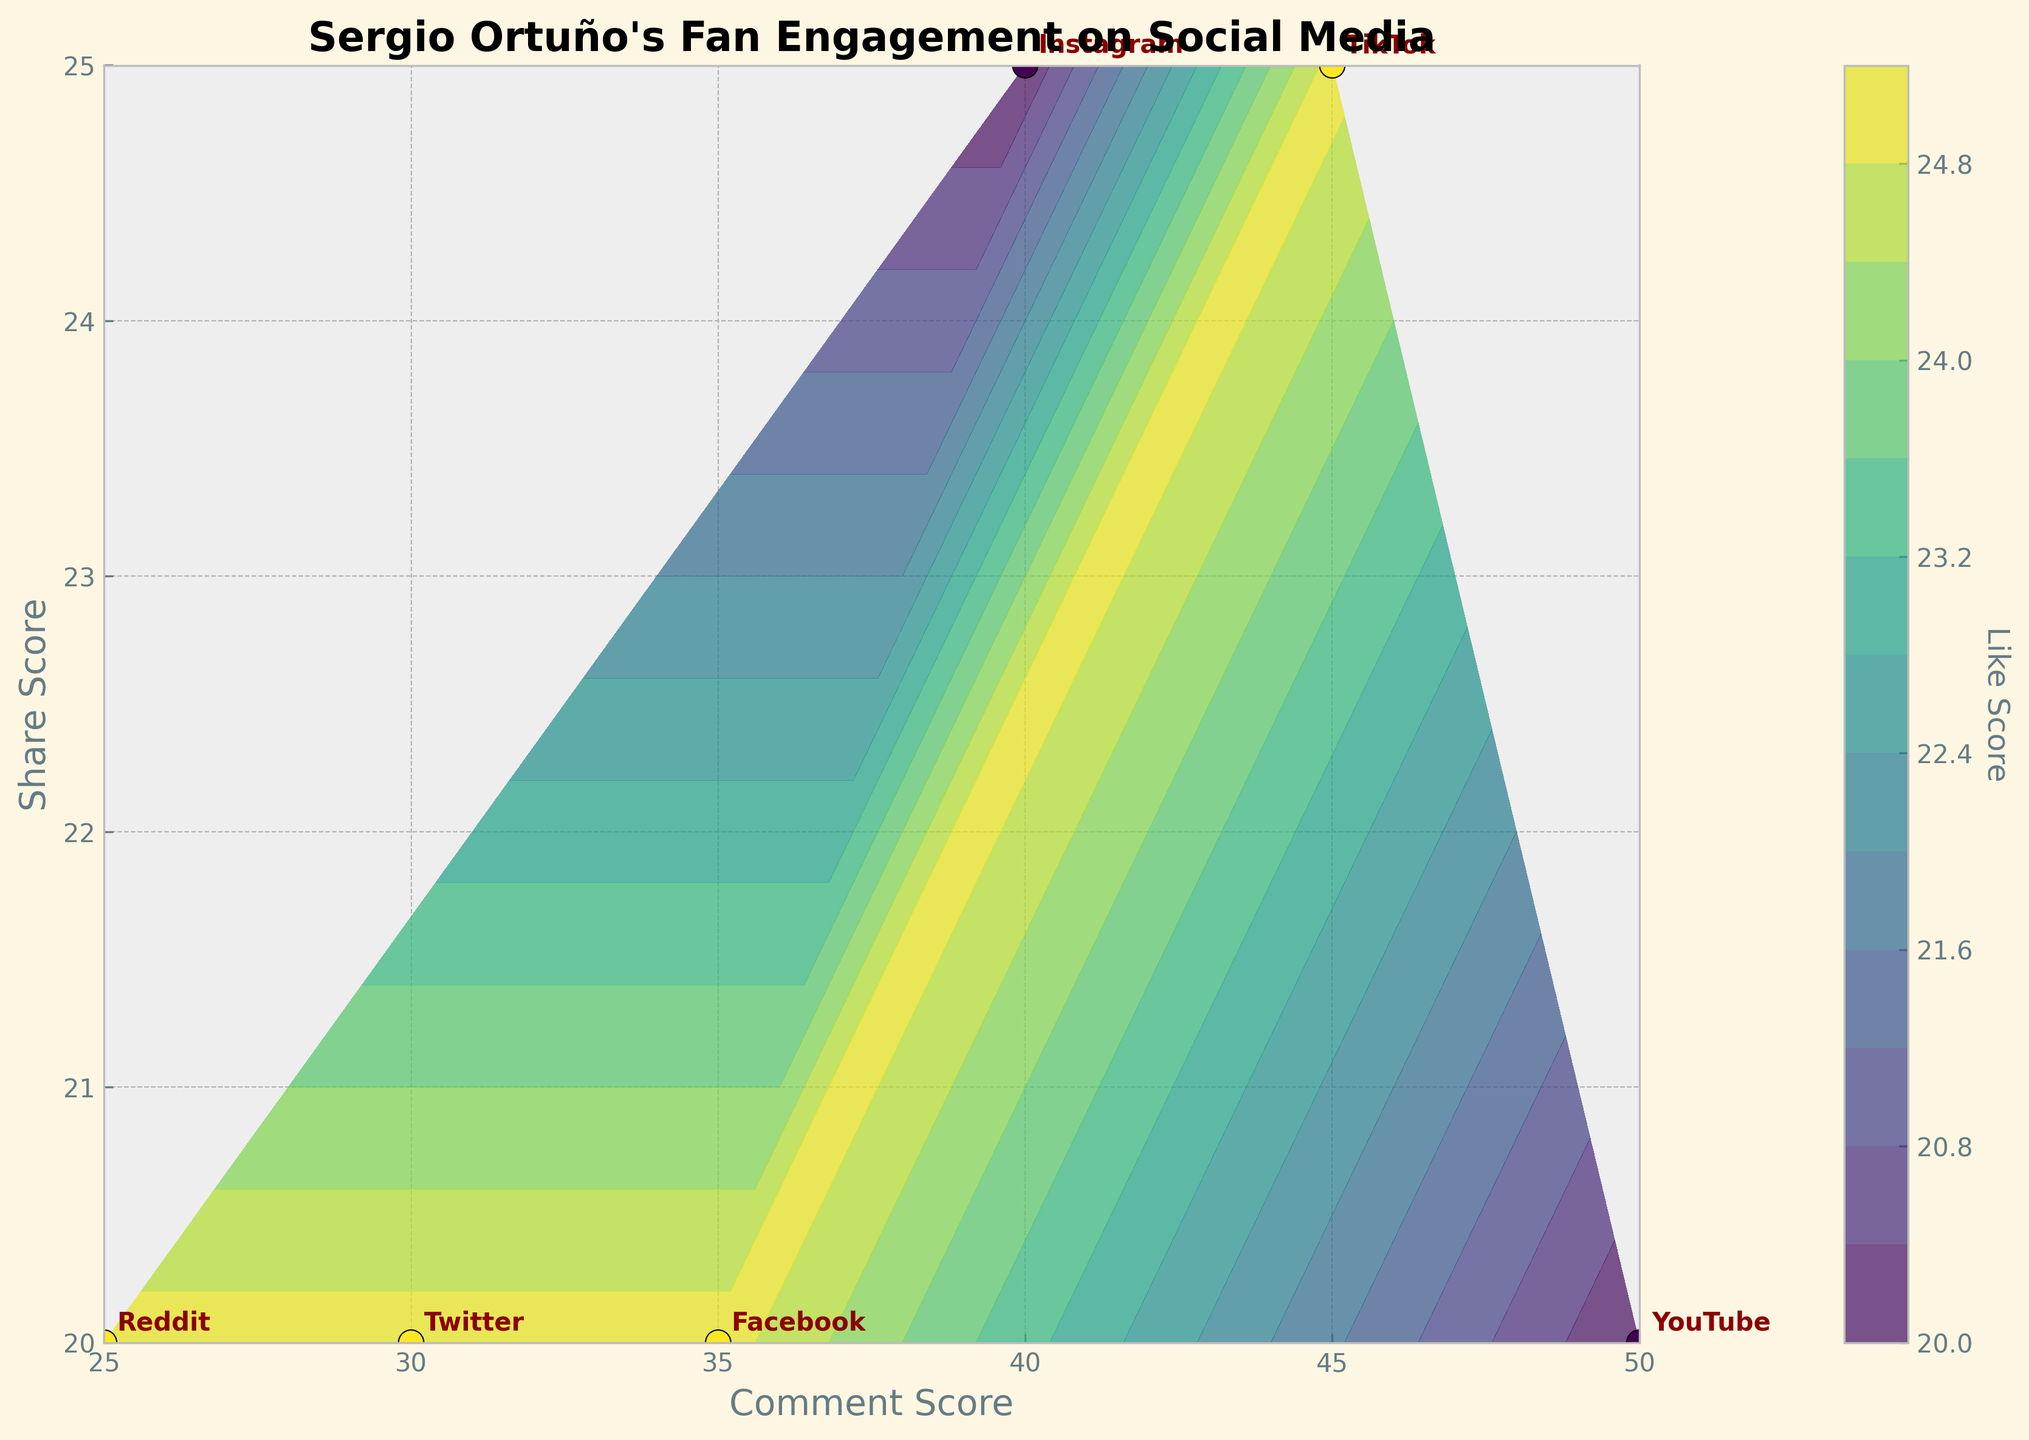What's the title of the plot? The title of the plot is usually displayed at the top center of the figure. In this case, it indicates the subject and purpose of the visualization.
Answer: Sergio Ortuño's Fan Engagement on Social Media How many data points are plotted on the scatter plot? Each platform has a corresponding point on the scatter plot, representing its engagement scores. By counting the number of annotated points, we see there are 6 points.
Answer: 6 Which platform has the highest engagement score? By interpreting the annotations, TikTok shows the highest values for all the scores, making it easily identifiable.
Answer: TikTok What are the axes labels? The axis labels provide information about what each axis represents. In this figure, the x-axis is labeled 'Comment Score' and the y-axis is labeled 'Share Score'.
Answer: Comment Score and Share Score How is the 'Like Score' represented in the plot? The 'Like Score' is represented using colors in the contour plot. The intensity of the color on the viridis scale indicates the 'Like Score' values.
Answer: Colors Which platform has the highest Like Score? To find the platform with the highest Like Score, locate the darkest point on the viridis color scale in the contour plot and observe its annotation. TikTok has the highest Like Score.
Answer: TikTok What's the average Share Score of all platforms? By summing up the Share Scores (20+20+25+20+25+20 = 130) and dividing by the number of platforms (6), we get the average Share Score.
Answer: 21.67 Compare the Comment Score and Share Score for Instagram. Is the Comment Score higher than the Share Score? Look at the annotated point for Instagram. The Comment Score is 40, and the Share Score is 25, so the Comment Score is indeed higher.
Answer: Yes Which platforms have the same Share Score? By checking the annotations, Twitter, Facebook, YouTube, and Reddit share a Share Score of 20.
Answer: Twitter, Facebook, YouTube, Reddit Identify the platform with the lowest Like Score. Locate the lightest colored point on the viridis scale in the contour plot. This point is annotated as Instagram.
Answer: Instagram 